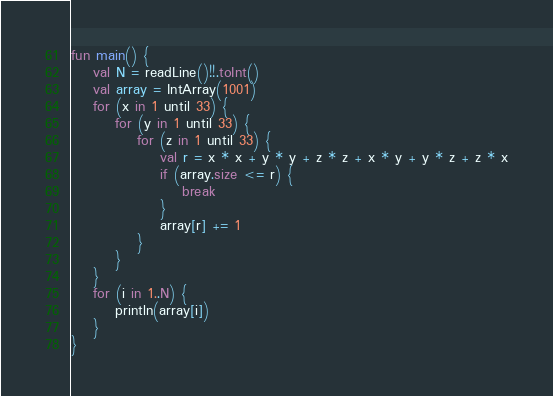<code> <loc_0><loc_0><loc_500><loc_500><_Kotlin_>fun main() {
    val N = readLine()!!.toInt()
    val array = IntArray(1001)
    for (x in 1 until 33) {
        for (y in 1 until 33) {
            for (z in 1 until 33) {
                val r = x * x + y * y + z * z + x * y + y * z + z * x
                if (array.size <= r) {
                    break
                }
                array[r] += 1
            }
        }
    }
    for (i in 1..N) {
        println(array[i])
    }
}
</code> 